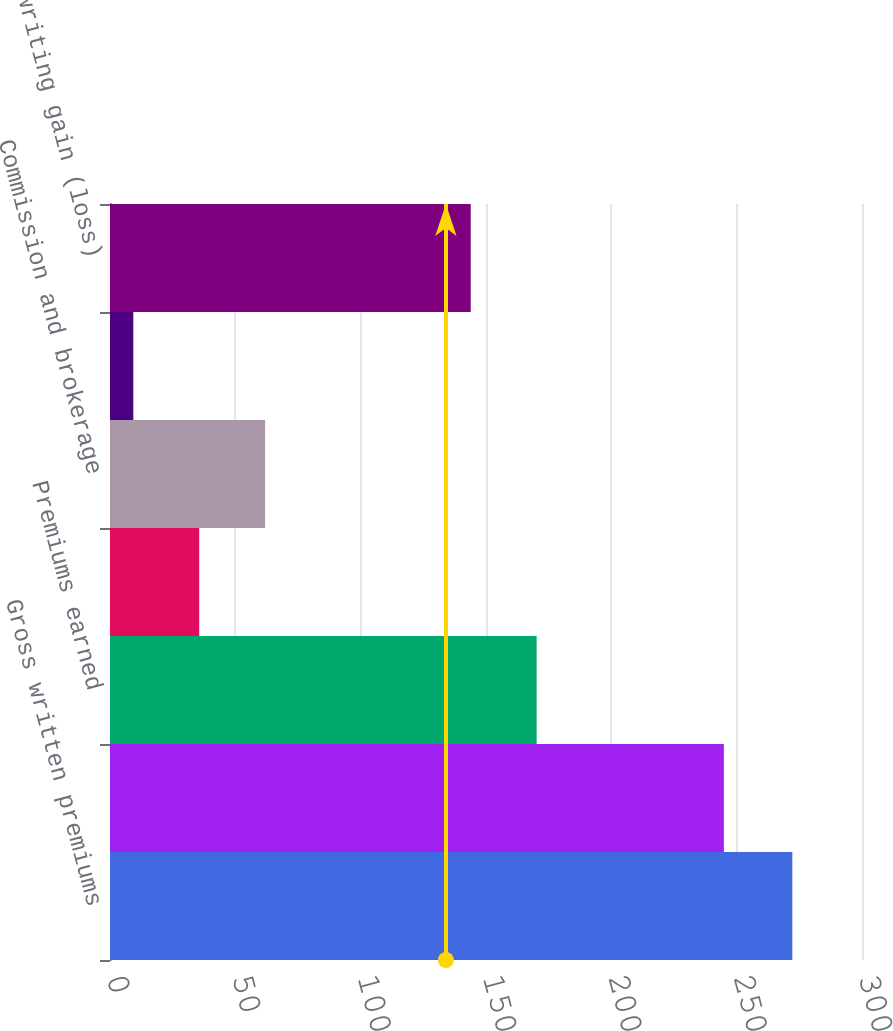<chart> <loc_0><loc_0><loc_500><loc_500><bar_chart><fcel>Gross written premiums<fcel>Net written premiums<fcel>Premiums earned<fcel>Incurred losses and LAE<fcel>Commission and brokerage<fcel>Other underwriting expenses<fcel>Underwriting gain (loss)<nl><fcel>272.2<fcel>244.9<fcel>170.2<fcel>35.59<fcel>61.88<fcel>9.3<fcel>143.9<nl></chart> 